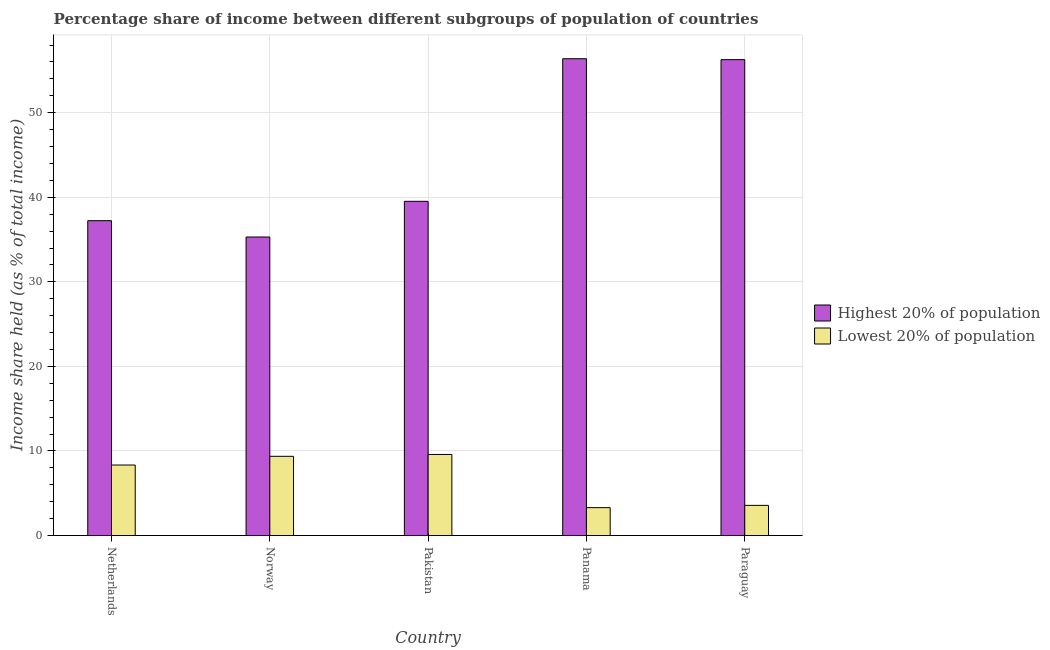How many groups of bars are there?
Give a very brief answer. 5. Are the number of bars per tick equal to the number of legend labels?
Your response must be concise. Yes. How many bars are there on the 5th tick from the left?
Offer a terse response. 2. How many bars are there on the 1st tick from the right?
Give a very brief answer. 2. What is the label of the 3rd group of bars from the left?
Your answer should be very brief. Pakistan. What is the income share held by lowest 20% of the population in Netherlands?
Make the answer very short. 8.34. Across all countries, what is the maximum income share held by lowest 20% of the population?
Keep it short and to the point. 9.59. Across all countries, what is the minimum income share held by lowest 20% of the population?
Offer a very short reply. 3.3. In which country was the income share held by highest 20% of the population maximum?
Your answer should be very brief. Panama. In which country was the income share held by highest 20% of the population minimum?
Provide a short and direct response. Norway. What is the total income share held by lowest 20% of the population in the graph?
Make the answer very short. 34.17. What is the difference between the income share held by highest 20% of the population in Panama and that in Paraguay?
Provide a succinct answer. 0.11. What is the difference between the income share held by highest 20% of the population in Norway and the income share held by lowest 20% of the population in Netherlands?
Your response must be concise. 26.96. What is the average income share held by lowest 20% of the population per country?
Make the answer very short. 6.83. What is the difference between the income share held by lowest 20% of the population and income share held by highest 20% of the population in Norway?
Your answer should be very brief. -25.93. In how many countries, is the income share held by lowest 20% of the population greater than 4 %?
Provide a short and direct response. 3. What is the ratio of the income share held by lowest 20% of the population in Pakistan to that in Paraguay?
Make the answer very short. 2.69. Is the difference between the income share held by highest 20% of the population in Norway and Pakistan greater than the difference between the income share held by lowest 20% of the population in Norway and Pakistan?
Your response must be concise. No. What is the difference between the highest and the second highest income share held by lowest 20% of the population?
Give a very brief answer. 0.22. What is the difference between the highest and the lowest income share held by lowest 20% of the population?
Provide a succinct answer. 6.29. What does the 1st bar from the left in Paraguay represents?
Your answer should be compact. Highest 20% of population. What does the 1st bar from the right in Panama represents?
Your answer should be compact. Lowest 20% of population. How many bars are there?
Your answer should be very brief. 10. Are the values on the major ticks of Y-axis written in scientific E-notation?
Ensure brevity in your answer.  No. What is the title of the graph?
Keep it short and to the point. Percentage share of income between different subgroups of population of countries. What is the label or title of the Y-axis?
Provide a short and direct response. Income share held (as % of total income). What is the Income share held (as % of total income) in Highest 20% of population in Netherlands?
Offer a terse response. 37.23. What is the Income share held (as % of total income) of Lowest 20% of population in Netherlands?
Provide a short and direct response. 8.34. What is the Income share held (as % of total income) of Highest 20% of population in Norway?
Keep it short and to the point. 35.3. What is the Income share held (as % of total income) in Lowest 20% of population in Norway?
Provide a short and direct response. 9.37. What is the Income share held (as % of total income) in Highest 20% of population in Pakistan?
Your answer should be compact. 39.52. What is the Income share held (as % of total income) of Lowest 20% of population in Pakistan?
Your answer should be compact. 9.59. What is the Income share held (as % of total income) in Highest 20% of population in Panama?
Make the answer very short. 56.38. What is the Income share held (as % of total income) of Lowest 20% of population in Panama?
Provide a short and direct response. 3.3. What is the Income share held (as % of total income) in Highest 20% of population in Paraguay?
Your answer should be very brief. 56.27. What is the Income share held (as % of total income) in Lowest 20% of population in Paraguay?
Your response must be concise. 3.57. Across all countries, what is the maximum Income share held (as % of total income) of Highest 20% of population?
Your answer should be very brief. 56.38. Across all countries, what is the maximum Income share held (as % of total income) in Lowest 20% of population?
Give a very brief answer. 9.59. Across all countries, what is the minimum Income share held (as % of total income) in Highest 20% of population?
Provide a succinct answer. 35.3. Across all countries, what is the minimum Income share held (as % of total income) in Lowest 20% of population?
Your answer should be very brief. 3.3. What is the total Income share held (as % of total income) in Highest 20% of population in the graph?
Offer a very short reply. 224.7. What is the total Income share held (as % of total income) of Lowest 20% of population in the graph?
Offer a terse response. 34.17. What is the difference between the Income share held (as % of total income) in Highest 20% of population in Netherlands and that in Norway?
Your answer should be compact. 1.93. What is the difference between the Income share held (as % of total income) of Lowest 20% of population in Netherlands and that in Norway?
Offer a terse response. -1.03. What is the difference between the Income share held (as % of total income) of Highest 20% of population in Netherlands and that in Pakistan?
Your answer should be very brief. -2.29. What is the difference between the Income share held (as % of total income) in Lowest 20% of population in Netherlands and that in Pakistan?
Make the answer very short. -1.25. What is the difference between the Income share held (as % of total income) of Highest 20% of population in Netherlands and that in Panama?
Provide a succinct answer. -19.15. What is the difference between the Income share held (as % of total income) in Lowest 20% of population in Netherlands and that in Panama?
Offer a very short reply. 5.04. What is the difference between the Income share held (as % of total income) in Highest 20% of population in Netherlands and that in Paraguay?
Make the answer very short. -19.04. What is the difference between the Income share held (as % of total income) in Lowest 20% of population in Netherlands and that in Paraguay?
Ensure brevity in your answer.  4.77. What is the difference between the Income share held (as % of total income) of Highest 20% of population in Norway and that in Pakistan?
Keep it short and to the point. -4.22. What is the difference between the Income share held (as % of total income) in Lowest 20% of population in Norway and that in Pakistan?
Keep it short and to the point. -0.22. What is the difference between the Income share held (as % of total income) of Highest 20% of population in Norway and that in Panama?
Your answer should be very brief. -21.08. What is the difference between the Income share held (as % of total income) of Lowest 20% of population in Norway and that in Panama?
Your response must be concise. 6.07. What is the difference between the Income share held (as % of total income) in Highest 20% of population in Norway and that in Paraguay?
Make the answer very short. -20.97. What is the difference between the Income share held (as % of total income) in Highest 20% of population in Pakistan and that in Panama?
Ensure brevity in your answer.  -16.86. What is the difference between the Income share held (as % of total income) in Lowest 20% of population in Pakistan and that in Panama?
Ensure brevity in your answer.  6.29. What is the difference between the Income share held (as % of total income) of Highest 20% of population in Pakistan and that in Paraguay?
Give a very brief answer. -16.75. What is the difference between the Income share held (as % of total income) of Lowest 20% of population in Pakistan and that in Paraguay?
Give a very brief answer. 6.02. What is the difference between the Income share held (as % of total income) of Highest 20% of population in Panama and that in Paraguay?
Provide a short and direct response. 0.11. What is the difference between the Income share held (as % of total income) in Lowest 20% of population in Panama and that in Paraguay?
Keep it short and to the point. -0.27. What is the difference between the Income share held (as % of total income) of Highest 20% of population in Netherlands and the Income share held (as % of total income) of Lowest 20% of population in Norway?
Make the answer very short. 27.86. What is the difference between the Income share held (as % of total income) in Highest 20% of population in Netherlands and the Income share held (as % of total income) in Lowest 20% of population in Pakistan?
Offer a very short reply. 27.64. What is the difference between the Income share held (as % of total income) in Highest 20% of population in Netherlands and the Income share held (as % of total income) in Lowest 20% of population in Panama?
Offer a terse response. 33.93. What is the difference between the Income share held (as % of total income) in Highest 20% of population in Netherlands and the Income share held (as % of total income) in Lowest 20% of population in Paraguay?
Give a very brief answer. 33.66. What is the difference between the Income share held (as % of total income) in Highest 20% of population in Norway and the Income share held (as % of total income) in Lowest 20% of population in Pakistan?
Provide a short and direct response. 25.71. What is the difference between the Income share held (as % of total income) in Highest 20% of population in Norway and the Income share held (as % of total income) in Lowest 20% of population in Paraguay?
Your answer should be very brief. 31.73. What is the difference between the Income share held (as % of total income) in Highest 20% of population in Pakistan and the Income share held (as % of total income) in Lowest 20% of population in Panama?
Your answer should be very brief. 36.22. What is the difference between the Income share held (as % of total income) of Highest 20% of population in Pakistan and the Income share held (as % of total income) of Lowest 20% of population in Paraguay?
Make the answer very short. 35.95. What is the difference between the Income share held (as % of total income) in Highest 20% of population in Panama and the Income share held (as % of total income) in Lowest 20% of population in Paraguay?
Ensure brevity in your answer.  52.81. What is the average Income share held (as % of total income) in Highest 20% of population per country?
Your answer should be compact. 44.94. What is the average Income share held (as % of total income) in Lowest 20% of population per country?
Your answer should be compact. 6.83. What is the difference between the Income share held (as % of total income) of Highest 20% of population and Income share held (as % of total income) of Lowest 20% of population in Netherlands?
Give a very brief answer. 28.89. What is the difference between the Income share held (as % of total income) of Highest 20% of population and Income share held (as % of total income) of Lowest 20% of population in Norway?
Ensure brevity in your answer.  25.93. What is the difference between the Income share held (as % of total income) of Highest 20% of population and Income share held (as % of total income) of Lowest 20% of population in Pakistan?
Give a very brief answer. 29.93. What is the difference between the Income share held (as % of total income) of Highest 20% of population and Income share held (as % of total income) of Lowest 20% of population in Panama?
Your response must be concise. 53.08. What is the difference between the Income share held (as % of total income) of Highest 20% of population and Income share held (as % of total income) of Lowest 20% of population in Paraguay?
Ensure brevity in your answer.  52.7. What is the ratio of the Income share held (as % of total income) in Highest 20% of population in Netherlands to that in Norway?
Provide a succinct answer. 1.05. What is the ratio of the Income share held (as % of total income) of Lowest 20% of population in Netherlands to that in Norway?
Offer a terse response. 0.89. What is the ratio of the Income share held (as % of total income) of Highest 20% of population in Netherlands to that in Pakistan?
Your answer should be very brief. 0.94. What is the ratio of the Income share held (as % of total income) of Lowest 20% of population in Netherlands to that in Pakistan?
Your response must be concise. 0.87. What is the ratio of the Income share held (as % of total income) in Highest 20% of population in Netherlands to that in Panama?
Make the answer very short. 0.66. What is the ratio of the Income share held (as % of total income) in Lowest 20% of population in Netherlands to that in Panama?
Make the answer very short. 2.53. What is the ratio of the Income share held (as % of total income) in Highest 20% of population in Netherlands to that in Paraguay?
Provide a short and direct response. 0.66. What is the ratio of the Income share held (as % of total income) of Lowest 20% of population in Netherlands to that in Paraguay?
Provide a succinct answer. 2.34. What is the ratio of the Income share held (as % of total income) in Highest 20% of population in Norway to that in Pakistan?
Keep it short and to the point. 0.89. What is the ratio of the Income share held (as % of total income) of Lowest 20% of population in Norway to that in Pakistan?
Provide a short and direct response. 0.98. What is the ratio of the Income share held (as % of total income) of Highest 20% of population in Norway to that in Panama?
Keep it short and to the point. 0.63. What is the ratio of the Income share held (as % of total income) in Lowest 20% of population in Norway to that in Panama?
Give a very brief answer. 2.84. What is the ratio of the Income share held (as % of total income) of Highest 20% of population in Norway to that in Paraguay?
Make the answer very short. 0.63. What is the ratio of the Income share held (as % of total income) in Lowest 20% of population in Norway to that in Paraguay?
Your answer should be compact. 2.62. What is the ratio of the Income share held (as % of total income) in Highest 20% of population in Pakistan to that in Panama?
Give a very brief answer. 0.7. What is the ratio of the Income share held (as % of total income) in Lowest 20% of population in Pakistan to that in Panama?
Give a very brief answer. 2.91. What is the ratio of the Income share held (as % of total income) in Highest 20% of population in Pakistan to that in Paraguay?
Offer a very short reply. 0.7. What is the ratio of the Income share held (as % of total income) in Lowest 20% of population in Pakistan to that in Paraguay?
Ensure brevity in your answer.  2.69. What is the ratio of the Income share held (as % of total income) in Highest 20% of population in Panama to that in Paraguay?
Your response must be concise. 1. What is the ratio of the Income share held (as % of total income) of Lowest 20% of population in Panama to that in Paraguay?
Make the answer very short. 0.92. What is the difference between the highest and the second highest Income share held (as % of total income) of Highest 20% of population?
Your response must be concise. 0.11. What is the difference between the highest and the second highest Income share held (as % of total income) in Lowest 20% of population?
Your answer should be compact. 0.22. What is the difference between the highest and the lowest Income share held (as % of total income) in Highest 20% of population?
Ensure brevity in your answer.  21.08. What is the difference between the highest and the lowest Income share held (as % of total income) in Lowest 20% of population?
Provide a short and direct response. 6.29. 